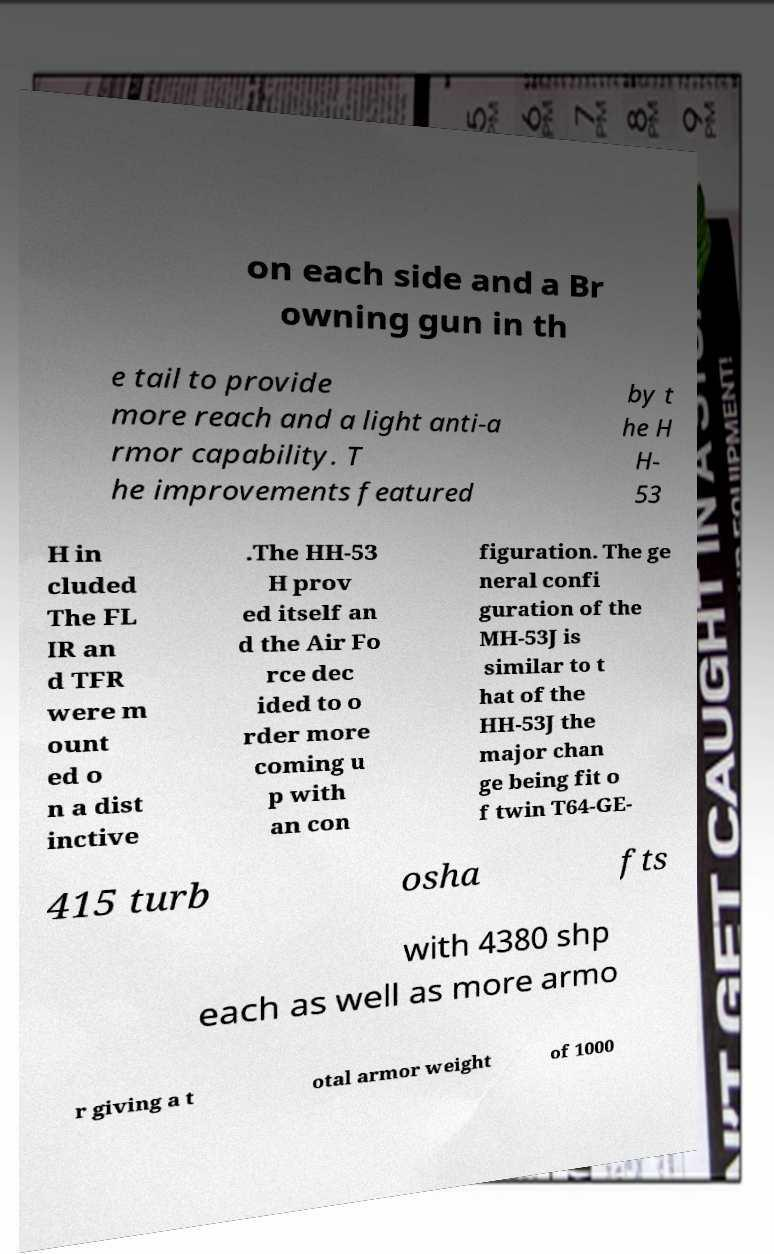Please identify and transcribe the text found in this image. on each side and a Br owning gun in th e tail to provide more reach and a light anti-a rmor capability. T he improvements featured by t he H H- 53 H in cluded The FL IR an d TFR were m ount ed o n a dist inctive .The HH-53 H prov ed itself an d the Air Fo rce dec ided to o rder more coming u p with an con figuration. The ge neral confi guration of the MH-53J is similar to t hat of the HH-53J the major chan ge being fit o f twin T64-GE- 415 turb osha fts with 4380 shp each as well as more armo r giving a t otal armor weight of 1000 